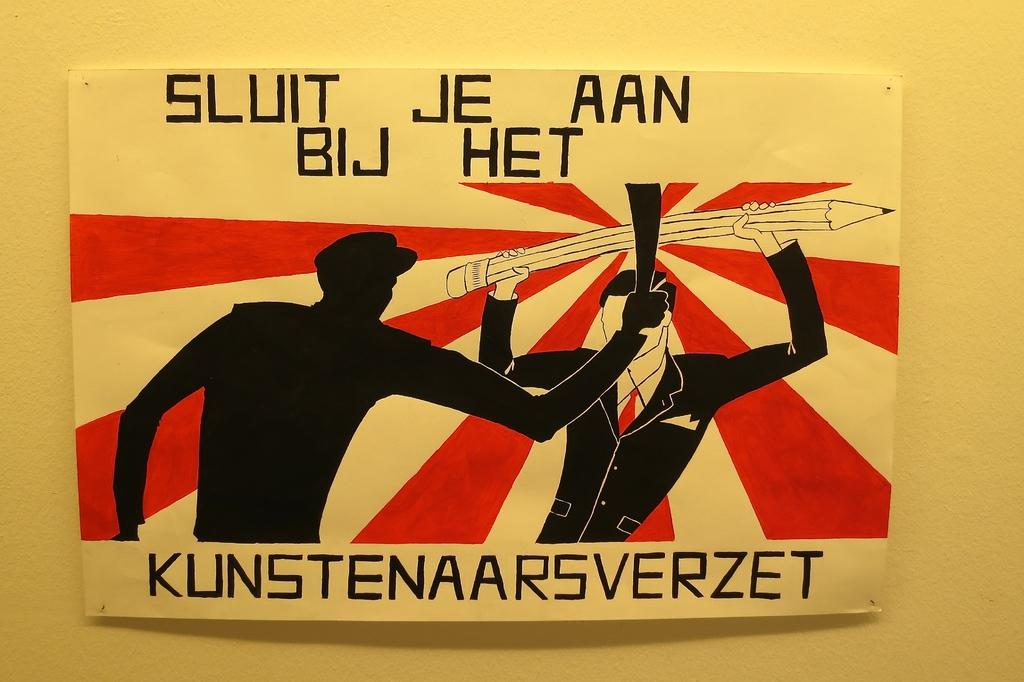<image>
Write a terse but informative summary of the picture. A painting in black, cream, and red shows two men and says, "Sluit Je Aan Bij Het". 